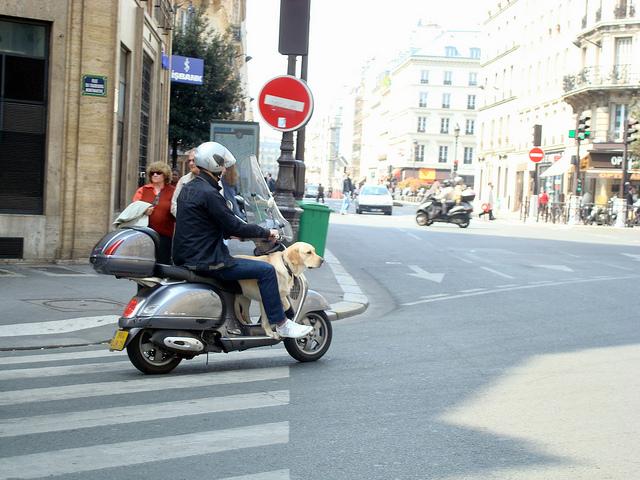What color is the moped?
Keep it brief. Silver. Which way is the man turning on the motorcycle?
Give a very brief answer. Left. Is it sunny?
Give a very brief answer. Yes. What color is the traffic sign?
Short answer required. Red. What color is the person's helmet?
Give a very brief answer. White. 